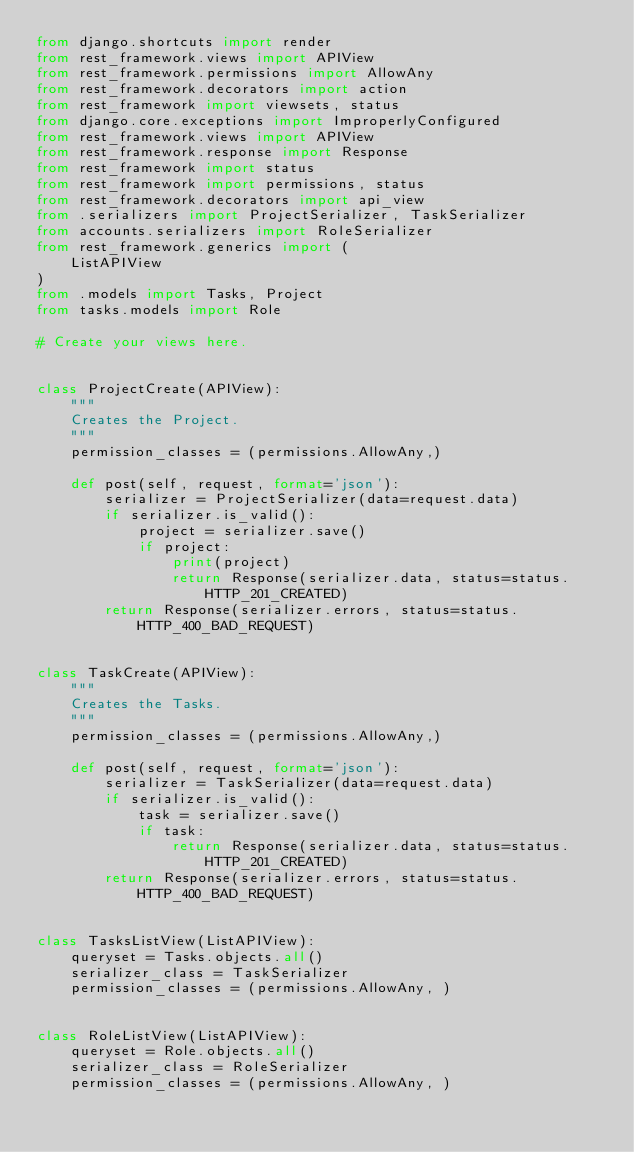<code> <loc_0><loc_0><loc_500><loc_500><_Python_>from django.shortcuts import render
from rest_framework.views import APIView
from rest_framework.permissions import AllowAny
from rest_framework.decorators import action
from rest_framework import viewsets, status
from django.core.exceptions import ImproperlyConfigured
from rest_framework.views import APIView
from rest_framework.response import Response
from rest_framework import status
from rest_framework import permissions, status
from rest_framework.decorators import api_view
from .serializers import ProjectSerializer, TaskSerializer
from accounts.serializers import RoleSerializer
from rest_framework.generics import (
    ListAPIView
)
from .models import Tasks, Project
from tasks.models import Role

# Create your views here.


class ProjectCreate(APIView):
    """ 
    Creates the Project. 
    """
    permission_classes = (permissions.AllowAny,)

    def post(self, request, format='json'):
        serializer = ProjectSerializer(data=request.data)
        if serializer.is_valid():
            project = serializer.save()
            if project:
                print(project)
                return Response(serializer.data, status=status.HTTP_201_CREATED)
        return Response(serializer.errors, status=status.HTTP_400_BAD_REQUEST)


class TaskCreate(APIView):
    """ 
    Creates the Tasks. 
    """
    permission_classes = (permissions.AllowAny,)

    def post(self, request, format='json'):
        serializer = TaskSerializer(data=request.data)
        if serializer.is_valid():
            task = serializer.save()
            if task:
                return Response(serializer.data, status=status.HTTP_201_CREATED)
        return Response(serializer.errors, status=status.HTTP_400_BAD_REQUEST)


class TasksListView(ListAPIView):
    queryset = Tasks.objects.all()
    serializer_class = TaskSerializer
    permission_classes = (permissions.AllowAny, )


class RoleListView(ListAPIView):
    queryset = Role.objects.all()
    serializer_class = RoleSerializer
    permission_classes = (permissions.AllowAny, )
</code> 